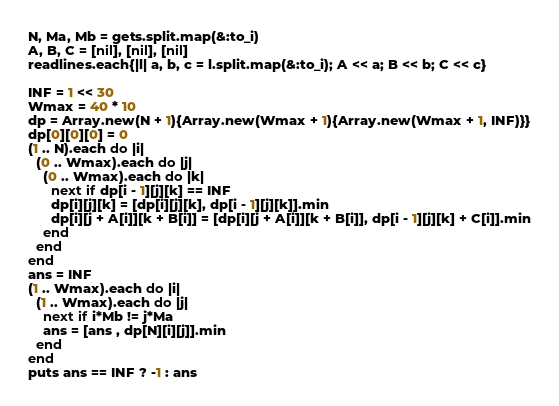Convert code to text. <code><loc_0><loc_0><loc_500><loc_500><_Ruby_>N, Ma, Mb = gets.split.map(&:to_i)
A, B, C = [nil], [nil], [nil]
readlines.each{|l| a, b, c = l.split.map(&:to_i); A << a; B << b; C << c}

INF = 1 << 30
Wmax = 40 * 10
dp = Array.new(N + 1){Array.new(Wmax + 1){Array.new(Wmax + 1, INF)}}
dp[0][0][0] = 0
(1 .. N).each do |i|
  (0 .. Wmax).each do |j|
    (0 .. Wmax).each do |k|
      next if dp[i - 1][j][k] == INF
      dp[i][j][k] = [dp[i][j][k], dp[i - 1][j][k]].min
      dp[i][j + A[i]][k + B[i]] = [dp[i][j + A[i]][k + B[i]], dp[i - 1][j][k] + C[i]].min
    end
  end
end
ans = INF
(1 .. Wmax).each do |i|
  (1 .. Wmax).each do |j|
    next if i*Mb != j*Ma
    ans = [ans , dp[N][i][j]].min
  end
end
puts ans == INF ? -1 : ans
</code> 